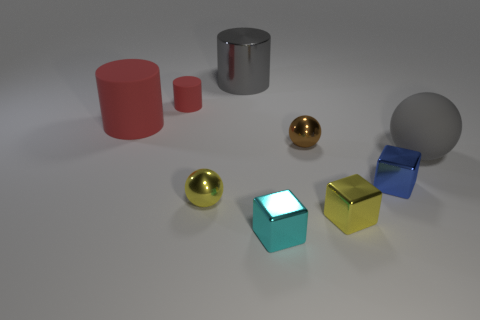Add 1 cyan blocks. How many objects exist? 10 Subtract all spheres. How many objects are left? 6 Subtract all tiny cyan shiny balls. Subtract all big gray matte objects. How many objects are left? 8 Add 2 brown metallic balls. How many brown metallic balls are left? 3 Add 5 big yellow metal blocks. How many big yellow metal blocks exist? 5 Subtract 0 green blocks. How many objects are left? 9 